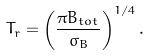Convert formula to latex. <formula><loc_0><loc_0><loc_500><loc_500>T _ { r } = \left ( \frac { \pi B _ { t o t } } { \sigma _ { B } } \right ) ^ { 1 / 4 } .</formula> 